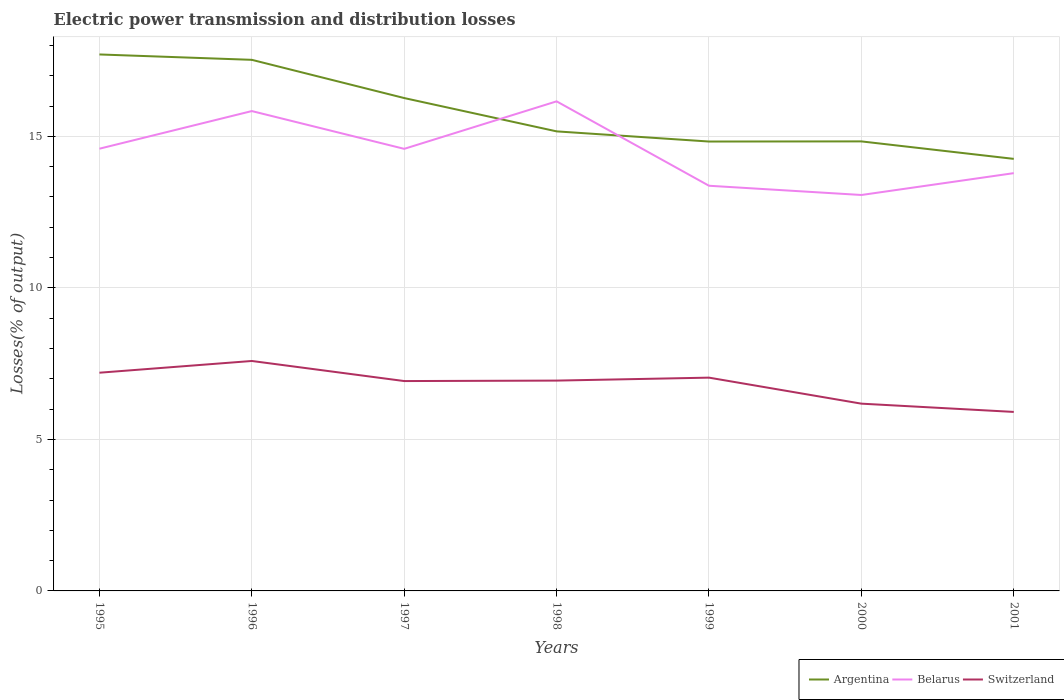How many different coloured lines are there?
Your answer should be compact. 3. Does the line corresponding to Belarus intersect with the line corresponding to Switzerland?
Offer a very short reply. No. Across all years, what is the maximum electric power transmission and distribution losses in Argentina?
Provide a short and direct response. 14.26. What is the total electric power transmission and distribution losses in Switzerland in the graph?
Give a very brief answer. 1.03. What is the difference between the highest and the second highest electric power transmission and distribution losses in Argentina?
Provide a succinct answer. 3.45. What is the difference between the highest and the lowest electric power transmission and distribution losses in Belarus?
Offer a terse response. 4. Is the electric power transmission and distribution losses in Argentina strictly greater than the electric power transmission and distribution losses in Switzerland over the years?
Your answer should be compact. No. How many years are there in the graph?
Ensure brevity in your answer.  7. What is the difference between two consecutive major ticks on the Y-axis?
Give a very brief answer. 5. Does the graph contain any zero values?
Keep it short and to the point. No. How many legend labels are there?
Offer a very short reply. 3. What is the title of the graph?
Keep it short and to the point. Electric power transmission and distribution losses. Does "Sint Maarten (Dutch part)" appear as one of the legend labels in the graph?
Give a very brief answer. No. What is the label or title of the Y-axis?
Provide a short and direct response. Losses(% of output). What is the Losses(% of output) of Argentina in 1995?
Give a very brief answer. 17.7. What is the Losses(% of output) in Belarus in 1995?
Ensure brevity in your answer.  14.59. What is the Losses(% of output) in Switzerland in 1995?
Your answer should be compact. 7.2. What is the Losses(% of output) in Argentina in 1996?
Provide a short and direct response. 17.52. What is the Losses(% of output) of Belarus in 1996?
Your answer should be very brief. 15.83. What is the Losses(% of output) of Switzerland in 1996?
Give a very brief answer. 7.59. What is the Losses(% of output) in Argentina in 1997?
Offer a very short reply. 16.26. What is the Losses(% of output) of Belarus in 1997?
Your answer should be compact. 14.59. What is the Losses(% of output) in Switzerland in 1997?
Keep it short and to the point. 6.92. What is the Losses(% of output) in Argentina in 1998?
Offer a very short reply. 15.16. What is the Losses(% of output) in Belarus in 1998?
Provide a succinct answer. 16.15. What is the Losses(% of output) of Switzerland in 1998?
Ensure brevity in your answer.  6.94. What is the Losses(% of output) in Argentina in 1999?
Provide a succinct answer. 14.83. What is the Losses(% of output) of Belarus in 1999?
Offer a terse response. 13.37. What is the Losses(% of output) in Switzerland in 1999?
Offer a very short reply. 7.04. What is the Losses(% of output) in Argentina in 2000?
Your answer should be compact. 14.83. What is the Losses(% of output) of Belarus in 2000?
Your answer should be very brief. 13.06. What is the Losses(% of output) in Switzerland in 2000?
Make the answer very short. 6.18. What is the Losses(% of output) in Argentina in 2001?
Give a very brief answer. 14.26. What is the Losses(% of output) in Belarus in 2001?
Provide a succinct answer. 13.79. What is the Losses(% of output) in Switzerland in 2001?
Give a very brief answer. 5.91. Across all years, what is the maximum Losses(% of output) in Argentina?
Your answer should be very brief. 17.7. Across all years, what is the maximum Losses(% of output) in Belarus?
Keep it short and to the point. 16.15. Across all years, what is the maximum Losses(% of output) in Switzerland?
Make the answer very short. 7.59. Across all years, what is the minimum Losses(% of output) in Argentina?
Make the answer very short. 14.26. Across all years, what is the minimum Losses(% of output) of Belarus?
Offer a very short reply. 13.06. Across all years, what is the minimum Losses(% of output) in Switzerland?
Your answer should be very brief. 5.91. What is the total Losses(% of output) of Argentina in the graph?
Your response must be concise. 110.57. What is the total Losses(% of output) in Belarus in the graph?
Provide a succinct answer. 101.39. What is the total Losses(% of output) of Switzerland in the graph?
Your answer should be very brief. 47.78. What is the difference between the Losses(% of output) in Argentina in 1995 and that in 1996?
Your answer should be compact. 0.18. What is the difference between the Losses(% of output) in Belarus in 1995 and that in 1996?
Keep it short and to the point. -1.24. What is the difference between the Losses(% of output) of Switzerland in 1995 and that in 1996?
Provide a short and direct response. -0.39. What is the difference between the Losses(% of output) of Argentina in 1995 and that in 1997?
Provide a succinct answer. 1.44. What is the difference between the Losses(% of output) in Belarus in 1995 and that in 1997?
Your answer should be compact. 0. What is the difference between the Losses(% of output) of Switzerland in 1995 and that in 1997?
Your response must be concise. 0.28. What is the difference between the Losses(% of output) in Argentina in 1995 and that in 1998?
Your response must be concise. 2.54. What is the difference between the Losses(% of output) in Belarus in 1995 and that in 1998?
Provide a short and direct response. -1.56. What is the difference between the Losses(% of output) of Switzerland in 1995 and that in 1998?
Your answer should be compact. 0.26. What is the difference between the Losses(% of output) in Argentina in 1995 and that in 1999?
Your response must be concise. 2.87. What is the difference between the Losses(% of output) of Belarus in 1995 and that in 1999?
Give a very brief answer. 1.22. What is the difference between the Losses(% of output) in Switzerland in 1995 and that in 1999?
Offer a terse response. 0.16. What is the difference between the Losses(% of output) in Argentina in 1995 and that in 2000?
Your response must be concise. 2.87. What is the difference between the Losses(% of output) of Belarus in 1995 and that in 2000?
Make the answer very short. 1.53. What is the difference between the Losses(% of output) in Switzerland in 1995 and that in 2000?
Provide a short and direct response. 1.02. What is the difference between the Losses(% of output) of Argentina in 1995 and that in 2001?
Provide a short and direct response. 3.45. What is the difference between the Losses(% of output) of Belarus in 1995 and that in 2001?
Make the answer very short. 0.81. What is the difference between the Losses(% of output) in Switzerland in 1995 and that in 2001?
Your answer should be compact. 1.29. What is the difference between the Losses(% of output) in Argentina in 1996 and that in 1997?
Give a very brief answer. 1.26. What is the difference between the Losses(% of output) of Belarus in 1996 and that in 1997?
Provide a succinct answer. 1.25. What is the difference between the Losses(% of output) in Switzerland in 1996 and that in 1997?
Offer a terse response. 0.66. What is the difference between the Losses(% of output) of Argentina in 1996 and that in 1998?
Your answer should be very brief. 2.36. What is the difference between the Losses(% of output) in Belarus in 1996 and that in 1998?
Provide a succinct answer. -0.32. What is the difference between the Losses(% of output) of Switzerland in 1996 and that in 1998?
Ensure brevity in your answer.  0.65. What is the difference between the Losses(% of output) of Argentina in 1996 and that in 1999?
Provide a succinct answer. 2.7. What is the difference between the Losses(% of output) in Belarus in 1996 and that in 1999?
Your response must be concise. 2.46. What is the difference between the Losses(% of output) in Switzerland in 1996 and that in 1999?
Keep it short and to the point. 0.55. What is the difference between the Losses(% of output) in Argentina in 1996 and that in 2000?
Ensure brevity in your answer.  2.69. What is the difference between the Losses(% of output) in Belarus in 1996 and that in 2000?
Ensure brevity in your answer.  2.77. What is the difference between the Losses(% of output) of Switzerland in 1996 and that in 2000?
Give a very brief answer. 1.41. What is the difference between the Losses(% of output) of Argentina in 1996 and that in 2001?
Offer a very short reply. 3.27. What is the difference between the Losses(% of output) of Belarus in 1996 and that in 2001?
Ensure brevity in your answer.  2.05. What is the difference between the Losses(% of output) of Switzerland in 1996 and that in 2001?
Make the answer very short. 1.68. What is the difference between the Losses(% of output) in Argentina in 1997 and that in 1998?
Offer a terse response. 1.1. What is the difference between the Losses(% of output) in Belarus in 1997 and that in 1998?
Provide a short and direct response. -1.57. What is the difference between the Losses(% of output) in Switzerland in 1997 and that in 1998?
Keep it short and to the point. -0.02. What is the difference between the Losses(% of output) in Argentina in 1997 and that in 1999?
Offer a very short reply. 1.43. What is the difference between the Losses(% of output) in Belarus in 1997 and that in 1999?
Your response must be concise. 1.22. What is the difference between the Losses(% of output) of Switzerland in 1997 and that in 1999?
Your response must be concise. -0.11. What is the difference between the Losses(% of output) in Argentina in 1997 and that in 2000?
Ensure brevity in your answer.  1.43. What is the difference between the Losses(% of output) of Belarus in 1997 and that in 2000?
Your answer should be compact. 1.52. What is the difference between the Losses(% of output) in Switzerland in 1997 and that in 2000?
Your response must be concise. 0.75. What is the difference between the Losses(% of output) in Argentina in 1997 and that in 2001?
Offer a very short reply. 2.01. What is the difference between the Losses(% of output) in Belarus in 1997 and that in 2001?
Ensure brevity in your answer.  0.8. What is the difference between the Losses(% of output) of Switzerland in 1997 and that in 2001?
Provide a succinct answer. 1.02. What is the difference between the Losses(% of output) of Argentina in 1998 and that in 1999?
Your response must be concise. 0.34. What is the difference between the Losses(% of output) of Belarus in 1998 and that in 1999?
Provide a succinct answer. 2.79. What is the difference between the Losses(% of output) in Switzerland in 1998 and that in 1999?
Your answer should be very brief. -0.1. What is the difference between the Losses(% of output) in Argentina in 1998 and that in 2000?
Ensure brevity in your answer.  0.33. What is the difference between the Losses(% of output) of Belarus in 1998 and that in 2000?
Ensure brevity in your answer.  3.09. What is the difference between the Losses(% of output) in Switzerland in 1998 and that in 2000?
Your answer should be very brief. 0.76. What is the difference between the Losses(% of output) of Argentina in 1998 and that in 2001?
Ensure brevity in your answer.  0.91. What is the difference between the Losses(% of output) in Belarus in 1998 and that in 2001?
Provide a short and direct response. 2.37. What is the difference between the Losses(% of output) in Switzerland in 1998 and that in 2001?
Offer a terse response. 1.03. What is the difference between the Losses(% of output) of Argentina in 1999 and that in 2000?
Provide a succinct answer. -0. What is the difference between the Losses(% of output) in Belarus in 1999 and that in 2000?
Ensure brevity in your answer.  0.3. What is the difference between the Losses(% of output) of Switzerland in 1999 and that in 2000?
Your response must be concise. 0.86. What is the difference between the Losses(% of output) of Argentina in 1999 and that in 2001?
Offer a terse response. 0.57. What is the difference between the Losses(% of output) of Belarus in 1999 and that in 2001?
Offer a very short reply. -0.42. What is the difference between the Losses(% of output) in Switzerland in 1999 and that in 2001?
Offer a very short reply. 1.13. What is the difference between the Losses(% of output) in Argentina in 2000 and that in 2001?
Ensure brevity in your answer.  0.58. What is the difference between the Losses(% of output) in Belarus in 2000 and that in 2001?
Offer a very short reply. -0.72. What is the difference between the Losses(% of output) of Switzerland in 2000 and that in 2001?
Offer a very short reply. 0.27. What is the difference between the Losses(% of output) in Argentina in 1995 and the Losses(% of output) in Belarus in 1996?
Offer a terse response. 1.87. What is the difference between the Losses(% of output) of Argentina in 1995 and the Losses(% of output) of Switzerland in 1996?
Ensure brevity in your answer.  10.11. What is the difference between the Losses(% of output) of Belarus in 1995 and the Losses(% of output) of Switzerland in 1996?
Offer a very short reply. 7. What is the difference between the Losses(% of output) in Argentina in 1995 and the Losses(% of output) in Belarus in 1997?
Provide a short and direct response. 3.11. What is the difference between the Losses(% of output) of Argentina in 1995 and the Losses(% of output) of Switzerland in 1997?
Provide a short and direct response. 10.78. What is the difference between the Losses(% of output) of Belarus in 1995 and the Losses(% of output) of Switzerland in 1997?
Your answer should be compact. 7.67. What is the difference between the Losses(% of output) in Argentina in 1995 and the Losses(% of output) in Belarus in 1998?
Provide a succinct answer. 1.55. What is the difference between the Losses(% of output) in Argentina in 1995 and the Losses(% of output) in Switzerland in 1998?
Offer a terse response. 10.76. What is the difference between the Losses(% of output) of Belarus in 1995 and the Losses(% of output) of Switzerland in 1998?
Ensure brevity in your answer.  7.65. What is the difference between the Losses(% of output) of Argentina in 1995 and the Losses(% of output) of Belarus in 1999?
Provide a succinct answer. 4.33. What is the difference between the Losses(% of output) of Argentina in 1995 and the Losses(% of output) of Switzerland in 1999?
Provide a short and direct response. 10.66. What is the difference between the Losses(% of output) in Belarus in 1995 and the Losses(% of output) in Switzerland in 1999?
Your answer should be very brief. 7.55. What is the difference between the Losses(% of output) of Argentina in 1995 and the Losses(% of output) of Belarus in 2000?
Give a very brief answer. 4.64. What is the difference between the Losses(% of output) of Argentina in 1995 and the Losses(% of output) of Switzerland in 2000?
Provide a succinct answer. 11.52. What is the difference between the Losses(% of output) in Belarus in 1995 and the Losses(% of output) in Switzerland in 2000?
Ensure brevity in your answer.  8.41. What is the difference between the Losses(% of output) of Argentina in 1995 and the Losses(% of output) of Belarus in 2001?
Ensure brevity in your answer.  3.92. What is the difference between the Losses(% of output) in Argentina in 1995 and the Losses(% of output) in Switzerland in 2001?
Keep it short and to the point. 11.8. What is the difference between the Losses(% of output) in Belarus in 1995 and the Losses(% of output) in Switzerland in 2001?
Your answer should be very brief. 8.69. What is the difference between the Losses(% of output) of Argentina in 1996 and the Losses(% of output) of Belarus in 1997?
Ensure brevity in your answer.  2.94. What is the difference between the Losses(% of output) in Argentina in 1996 and the Losses(% of output) in Switzerland in 1997?
Ensure brevity in your answer.  10.6. What is the difference between the Losses(% of output) in Belarus in 1996 and the Losses(% of output) in Switzerland in 1997?
Keep it short and to the point. 8.91. What is the difference between the Losses(% of output) in Argentina in 1996 and the Losses(% of output) in Belarus in 1998?
Your answer should be compact. 1.37. What is the difference between the Losses(% of output) of Argentina in 1996 and the Losses(% of output) of Switzerland in 1998?
Provide a short and direct response. 10.58. What is the difference between the Losses(% of output) of Belarus in 1996 and the Losses(% of output) of Switzerland in 1998?
Make the answer very short. 8.89. What is the difference between the Losses(% of output) of Argentina in 1996 and the Losses(% of output) of Belarus in 1999?
Keep it short and to the point. 4.16. What is the difference between the Losses(% of output) in Argentina in 1996 and the Losses(% of output) in Switzerland in 1999?
Provide a succinct answer. 10.49. What is the difference between the Losses(% of output) in Belarus in 1996 and the Losses(% of output) in Switzerland in 1999?
Provide a short and direct response. 8.8. What is the difference between the Losses(% of output) in Argentina in 1996 and the Losses(% of output) in Belarus in 2000?
Your response must be concise. 4.46. What is the difference between the Losses(% of output) of Argentina in 1996 and the Losses(% of output) of Switzerland in 2000?
Ensure brevity in your answer.  11.35. What is the difference between the Losses(% of output) in Belarus in 1996 and the Losses(% of output) in Switzerland in 2000?
Offer a terse response. 9.65. What is the difference between the Losses(% of output) of Argentina in 1996 and the Losses(% of output) of Belarus in 2001?
Make the answer very short. 3.74. What is the difference between the Losses(% of output) in Argentina in 1996 and the Losses(% of output) in Switzerland in 2001?
Provide a short and direct response. 11.62. What is the difference between the Losses(% of output) in Belarus in 1996 and the Losses(% of output) in Switzerland in 2001?
Give a very brief answer. 9.93. What is the difference between the Losses(% of output) in Argentina in 1997 and the Losses(% of output) in Belarus in 1998?
Offer a very short reply. 0.11. What is the difference between the Losses(% of output) of Argentina in 1997 and the Losses(% of output) of Switzerland in 1998?
Ensure brevity in your answer.  9.32. What is the difference between the Losses(% of output) in Belarus in 1997 and the Losses(% of output) in Switzerland in 1998?
Offer a very short reply. 7.65. What is the difference between the Losses(% of output) of Argentina in 1997 and the Losses(% of output) of Belarus in 1999?
Your answer should be compact. 2.89. What is the difference between the Losses(% of output) of Argentina in 1997 and the Losses(% of output) of Switzerland in 1999?
Provide a succinct answer. 9.23. What is the difference between the Losses(% of output) of Belarus in 1997 and the Losses(% of output) of Switzerland in 1999?
Offer a very short reply. 7.55. What is the difference between the Losses(% of output) of Argentina in 1997 and the Losses(% of output) of Belarus in 2000?
Provide a short and direct response. 3.2. What is the difference between the Losses(% of output) of Argentina in 1997 and the Losses(% of output) of Switzerland in 2000?
Your answer should be very brief. 10.08. What is the difference between the Losses(% of output) of Belarus in 1997 and the Losses(% of output) of Switzerland in 2000?
Provide a succinct answer. 8.41. What is the difference between the Losses(% of output) in Argentina in 1997 and the Losses(% of output) in Belarus in 2001?
Your response must be concise. 2.48. What is the difference between the Losses(% of output) in Argentina in 1997 and the Losses(% of output) in Switzerland in 2001?
Provide a succinct answer. 10.36. What is the difference between the Losses(% of output) in Belarus in 1997 and the Losses(% of output) in Switzerland in 2001?
Your answer should be very brief. 8.68. What is the difference between the Losses(% of output) of Argentina in 1998 and the Losses(% of output) of Belarus in 1999?
Your answer should be compact. 1.79. What is the difference between the Losses(% of output) of Argentina in 1998 and the Losses(% of output) of Switzerland in 1999?
Offer a very short reply. 8.13. What is the difference between the Losses(% of output) in Belarus in 1998 and the Losses(% of output) in Switzerland in 1999?
Your answer should be compact. 9.12. What is the difference between the Losses(% of output) of Argentina in 1998 and the Losses(% of output) of Belarus in 2000?
Ensure brevity in your answer.  2.1. What is the difference between the Losses(% of output) in Argentina in 1998 and the Losses(% of output) in Switzerland in 2000?
Your answer should be compact. 8.98. What is the difference between the Losses(% of output) in Belarus in 1998 and the Losses(% of output) in Switzerland in 2000?
Provide a succinct answer. 9.98. What is the difference between the Losses(% of output) in Argentina in 1998 and the Losses(% of output) in Belarus in 2001?
Offer a very short reply. 1.38. What is the difference between the Losses(% of output) of Argentina in 1998 and the Losses(% of output) of Switzerland in 2001?
Offer a terse response. 9.26. What is the difference between the Losses(% of output) in Belarus in 1998 and the Losses(% of output) in Switzerland in 2001?
Offer a very short reply. 10.25. What is the difference between the Losses(% of output) of Argentina in 1999 and the Losses(% of output) of Belarus in 2000?
Offer a very short reply. 1.76. What is the difference between the Losses(% of output) in Argentina in 1999 and the Losses(% of output) in Switzerland in 2000?
Provide a succinct answer. 8.65. What is the difference between the Losses(% of output) of Belarus in 1999 and the Losses(% of output) of Switzerland in 2000?
Your response must be concise. 7.19. What is the difference between the Losses(% of output) in Argentina in 1999 and the Losses(% of output) in Belarus in 2001?
Your answer should be very brief. 1.04. What is the difference between the Losses(% of output) in Argentina in 1999 and the Losses(% of output) in Switzerland in 2001?
Your answer should be compact. 8.92. What is the difference between the Losses(% of output) in Belarus in 1999 and the Losses(% of output) in Switzerland in 2001?
Your answer should be very brief. 7.46. What is the difference between the Losses(% of output) in Argentina in 2000 and the Losses(% of output) in Belarus in 2001?
Your response must be concise. 1.05. What is the difference between the Losses(% of output) of Argentina in 2000 and the Losses(% of output) of Switzerland in 2001?
Offer a terse response. 8.93. What is the difference between the Losses(% of output) of Belarus in 2000 and the Losses(% of output) of Switzerland in 2001?
Your answer should be compact. 7.16. What is the average Losses(% of output) of Argentina per year?
Provide a short and direct response. 15.8. What is the average Losses(% of output) of Belarus per year?
Give a very brief answer. 14.48. What is the average Losses(% of output) in Switzerland per year?
Provide a succinct answer. 6.83. In the year 1995, what is the difference between the Losses(% of output) in Argentina and Losses(% of output) in Belarus?
Provide a short and direct response. 3.11. In the year 1995, what is the difference between the Losses(% of output) in Argentina and Losses(% of output) in Switzerland?
Offer a terse response. 10.5. In the year 1995, what is the difference between the Losses(% of output) of Belarus and Losses(% of output) of Switzerland?
Give a very brief answer. 7.39. In the year 1996, what is the difference between the Losses(% of output) of Argentina and Losses(% of output) of Belarus?
Offer a very short reply. 1.69. In the year 1996, what is the difference between the Losses(% of output) in Argentina and Losses(% of output) in Switzerland?
Provide a succinct answer. 9.94. In the year 1996, what is the difference between the Losses(% of output) in Belarus and Losses(% of output) in Switzerland?
Provide a succinct answer. 8.25. In the year 1997, what is the difference between the Losses(% of output) in Argentina and Losses(% of output) in Belarus?
Make the answer very short. 1.68. In the year 1997, what is the difference between the Losses(% of output) in Argentina and Losses(% of output) in Switzerland?
Offer a terse response. 9.34. In the year 1997, what is the difference between the Losses(% of output) of Belarus and Losses(% of output) of Switzerland?
Keep it short and to the point. 7.66. In the year 1998, what is the difference between the Losses(% of output) of Argentina and Losses(% of output) of Belarus?
Your answer should be compact. -0.99. In the year 1998, what is the difference between the Losses(% of output) in Argentina and Losses(% of output) in Switzerland?
Give a very brief answer. 8.22. In the year 1998, what is the difference between the Losses(% of output) in Belarus and Losses(% of output) in Switzerland?
Provide a succinct answer. 9.21. In the year 1999, what is the difference between the Losses(% of output) of Argentina and Losses(% of output) of Belarus?
Provide a short and direct response. 1.46. In the year 1999, what is the difference between the Losses(% of output) in Argentina and Losses(% of output) in Switzerland?
Your answer should be compact. 7.79. In the year 1999, what is the difference between the Losses(% of output) in Belarus and Losses(% of output) in Switzerland?
Your response must be concise. 6.33. In the year 2000, what is the difference between the Losses(% of output) of Argentina and Losses(% of output) of Belarus?
Provide a short and direct response. 1.77. In the year 2000, what is the difference between the Losses(% of output) in Argentina and Losses(% of output) in Switzerland?
Your answer should be compact. 8.65. In the year 2000, what is the difference between the Losses(% of output) of Belarus and Losses(% of output) of Switzerland?
Your answer should be very brief. 6.89. In the year 2001, what is the difference between the Losses(% of output) in Argentina and Losses(% of output) in Belarus?
Your answer should be very brief. 0.47. In the year 2001, what is the difference between the Losses(% of output) in Argentina and Losses(% of output) in Switzerland?
Your answer should be very brief. 8.35. In the year 2001, what is the difference between the Losses(% of output) in Belarus and Losses(% of output) in Switzerland?
Your answer should be compact. 7.88. What is the ratio of the Losses(% of output) in Argentina in 1995 to that in 1996?
Provide a short and direct response. 1.01. What is the ratio of the Losses(% of output) of Belarus in 1995 to that in 1996?
Provide a succinct answer. 0.92. What is the ratio of the Losses(% of output) of Switzerland in 1995 to that in 1996?
Give a very brief answer. 0.95. What is the ratio of the Losses(% of output) of Argentina in 1995 to that in 1997?
Provide a short and direct response. 1.09. What is the ratio of the Losses(% of output) in Belarus in 1995 to that in 1997?
Make the answer very short. 1. What is the ratio of the Losses(% of output) of Switzerland in 1995 to that in 1997?
Provide a short and direct response. 1.04. What is the ratio of the Losses(% of output) of Argentina in 1995 to that in 1998?
Offer a very short reply. 1.17. What is the ratio of the Losses(% of output) in Belarus in 1995 to that in 1998?
Provide a succinct answer. 0.9. What is the ratio of the Losses(% of output) of Switzerland in 1995 to that in 1998?
Make the answer very short. 1.04. What is the ratio of the Losses(% of output) in Argentina in 1995 to that in 1999?
Your response must be concise. 1.19. What is the ratio of the Losses(% of output) in Belarus in 1995 to that in 1999?
Your answer should be very brief. 1.09. What is the ratio of the Losses(% of output) of Switzerland in 1995 to that in 1999?
Offer a terse response. 1.02. What is the ratio of the Losses(% of output) of Argentina in 1995 to that in 2000?
Provide a succinct answer. 1.19. What is the ratio of the Losses(% of output) of Belarus in 1995 to that in 2000?
Provide a short and direct response. 1.12. What is the ratio of the Losses(% of output) in Switzerland in 1995 to that in 2000?
Ensure brevity in your answer.  1.17. What is the ratio of the Losses(% of output) in Argentina in 1995 to that in 2001?
Offer a terse response. 1.24. What is the ratio of the Losses(% of output) in Belarus in 1995 to that in 2001?
Make the answer very short. 1.06. What is the ratio of the Losses(% of output) in Switzerland in 1995 to that in 2001?
Offer a terse response. 1.22. What is the ratio of the Losses(% of output) in Argentina in 1996 to that in 1997?
Provide a succinct answer. 1.08. What is the ratio of the Losses(% of output) of Belarus in 1996 to that in 1997?
Provide a succinct answer. 1.09. What is the ratio of the Losses(% of output) of Switzerland in 1996 to that in 1997?
Provide a succinct answer. 1.1. What is the ratio of the Losses(% of output) of Argentina in 1996 to that in 1998?
Provide a short and direct response. 1.16. What is the ratio of the Losses(% of output) of Belarus in 1996 to that in 1998?
Keep it short and to the point. 0.98. What is the ratio of the Losses(% of output) in Switzerland in 1996 to that in 1998?
Your response must be concise. 1.09. What is the ratio of the Losses(% of output) of Argentina in 1996 to that in 1999?
Your answer should be very brief. 1.18. What is the ratio of the Losses(% of output) in Belarus in 1996 to that in 1999?
Offer a very short reply. 1.18. What is the ratio of the Losses(% of output) of Switzerland in 1996 to that in 1999?
Provide a succinct answer. 1.08. What is the ratio of the Losses(% of output) of Argentina in 1996 to that in 2000?
Your response must be concise. 1.18. What is the ratio of the Losses(% of output) in Belarus in 1996 to that in 2000?
Ensure brevity in your answer.  1.21. What is the ratio of the Losses(% of output) of Switzerland in 1996 to that in 2000?
Your answer should be very brief. 1.23. What is the ratio of the Losses(% of output) of Argentina in 1996 to that in 2001?
Offer a terse response. 1.23. What is the ratio of the Losses(% of output) in Belarus in 1996 to that in 2001?
Ensure brevity in your answer.  1.15. What is the ratio of the Losses(% of output) in Switzerland in 1996 to that in 2001?
Make the answer very short. 1.28. What is the ratio of the Losses(% of output) of Argentina in 1997 to that in 1998?
Make the answer very short. 1.07. What is the ratio of the Losses(% of output) in Belarus in 1997 to that in 1998?
Offer a terse response. 0.9. What is the ratio of the Losses(% of output) of Switzerland in 1997 to that in 1998?
Your answer should be very brief. 1. What is the ratio of the Losses(% of output) in Argentina in 1997 to that in 1999?
Keep it short and to the point. 1.1. What is the ratio of the Losses(% of output) of Belarus in 1997 to that in 1999?
Give a very brief answer. 1.09. What is the ratio of the Losses(% of output) in Switzerland in 1997 to that in 1999?
Your answer should be compact. 0.98. What is the ratio of the Losses(% of output) of Argentina in 1997 to that in 2000?
Make the answer very short. 1.1. What is the ratio of the Losses(% of output) in Belarus in 1997 to that in 2000?
Ensure brevity in your answer.  1.12. What is the ratio of the Losses(% of output) in Switzerland in 1997 to that in 2000?
Your answer should be very brief. 1.12. What is the ratio of the Losses(% of output) of Argentina in 1997 to that in 2001?
Ensure brevity in your answer.  1.14. What is the ratio of the Losses(% of output) in Belarus in 1997 to that in 2001?
Keep it short and to the point. 1.06. What is the ratio of the Losses(% of output) in Switzerland in 1997 to that in 2001?
Ensure brevity in your answer.  1.17. What is the ratio of the Losses(% of output) in Argentina in 1998 to that in 1999?
Offer a terse response. 1.02. What is the ratio of the Losses(% of output) of Belarus in 1998 to that in 1999?
Ensure brevity in your answer.  1.21. What is the ratio of the Losses(% of output) in Switzerland in 1998 to that in 1999?
Provide a short and direct response. 0.99. What is the ratio of the Losses(% of output) of Argentina in 1998 to that in 2000?
Give a very brief answer. 1.02. What is the ratio of the Losses(% of output) of Belarus in 1998 to that in 2000?
Your response must be concise. 1.24. What is the ratio of the Losses(% of output) of Switzerland in 1998 to that in 2000?
Your response must be concise. 1.12. What is the ratio of the Losses(% of output) in Argentina in 1998 to that in 2001?
Your answer should be compact. 1.06. What is the ratio of the Losses(% of output) in Belarus in 1998 to that in 2001?
Your response must be concise. 1.17. What is the ratio of the Losses(% of output) of Switzerland in 1998 to that in 2001?
Offer a terse response. 1.18. What is the ratio of the Losses(% of output) in Argentina in 1999 to that in 2000?
Your answer should be very brief. 1. What is the ratio of the Losses(% of output) in Belarus in 1999 to that in 2000?
Make the answer very short. 1.02. What is the ratio of the Losses(% of output) in Switzerland in 1999 to that in 2000?
Offer a terse response. 1.14. What is the ratio of the Losses(% of output) in Argentina in 1999 to that in 2001?
Provide a short and direct response. 1.04. What is the ratio of the Losses(% of output) of Belarus in 1999 to that in 2001?
Offer a terse response. 0.97. What is the ratio of the Losses(% of output) in Switzerland in 1999 to that in 2001?
Make the answer very short. 1.19. What is the ratio of the Losses(% of output) in Argentina in 2000 to that in 2001?
Your answer should be compact. 1.04. What is the ratio of the Losses(% of output) in Belarus in 2000 to that in 2001?
Make the answer very short. 0.95. What is the ratio of the Losses(% of output) of Switzerland in 2000 to that in 2001?
Offer a very short reply. 1.05. What is the difference between the highest and the second highest Losses(% of output) in Argentina?
Keep it short and to the point. 0.18. What is the difference between the highest and the second highest Losses(% of output) in Belarus?
Offer a very short reply. 0.32. What is the difference between the highest and the second highest Losses(% of output) of Switzerland?
Your response must be concise. 0.39. What is the difference between the highest and the lowest Losses(% of output) of Argentina?
Give a very brief answer. 3.45. What is the difference between the highest and the lowest Losses(% of output) of Belarus?
Your response must be concise. 3.09. What is the difference between the highest and the lowest Losses(% of output) of Switzerland?
Make the answer very short. 1.68. 